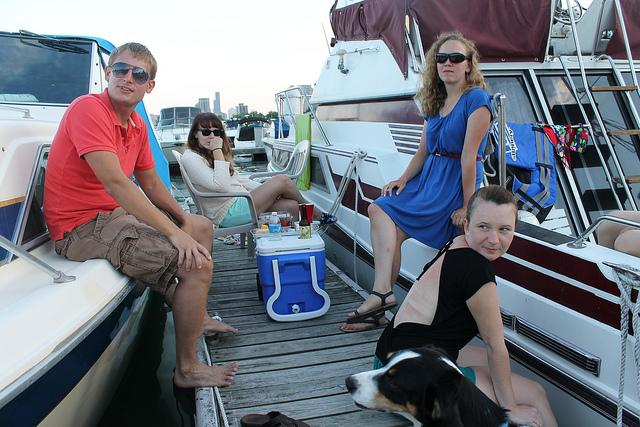Clothing items are hung here for which purpose? drying 